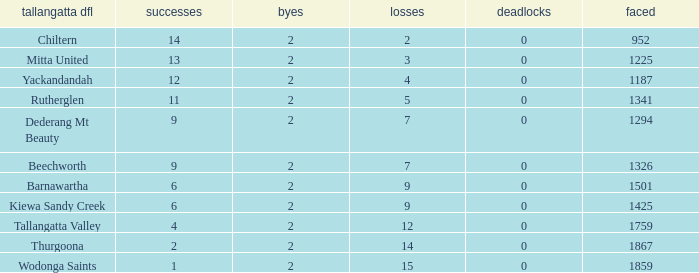What are the draws when wins are fwewer than 9 and byes fewer than 2? 0.0. 